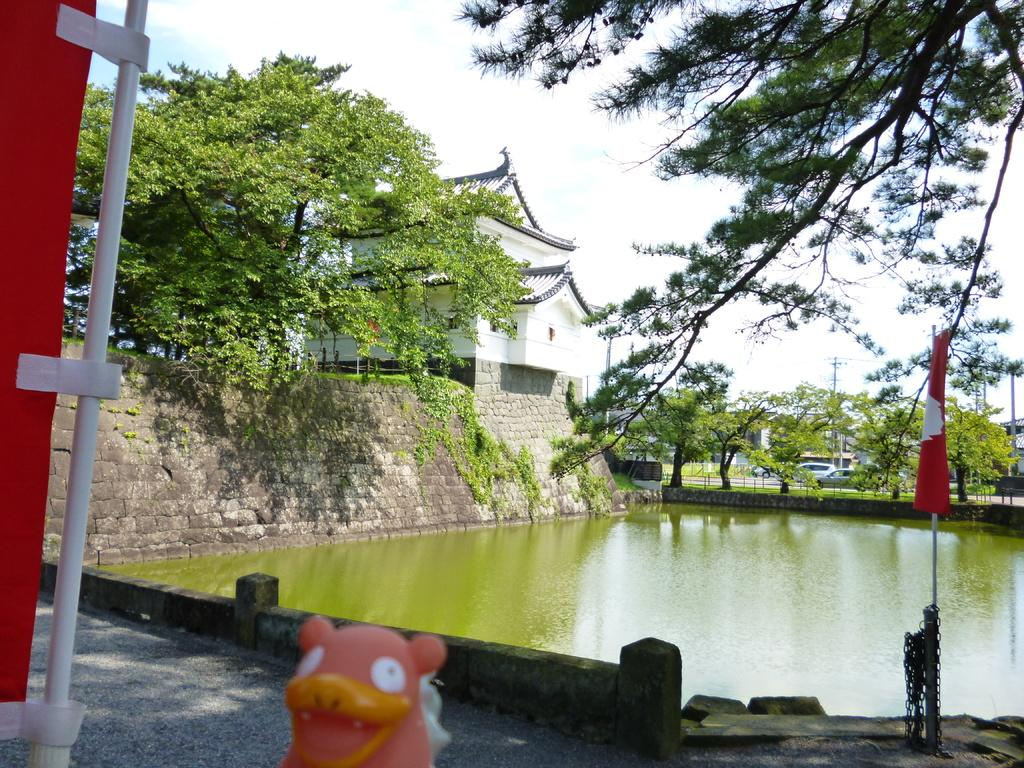What body of water is present in the image? There is a lake in the image. What type of vegetation surrounds the lake? There are trees around the lake. Are there any vehicles visible in the image? Yes, there are cars visible in the image. What type of structure can be seen in the image? There is a house in the image. Can you describe any other objects or structures present in the image? There are other unspecified objects or structures in the image. What type of beef is being served at the birthday party in the image? There is no indication of a birthday party or beef in the image; it features a lake, trees, cars, a house, and other unspecified objects or structures. 